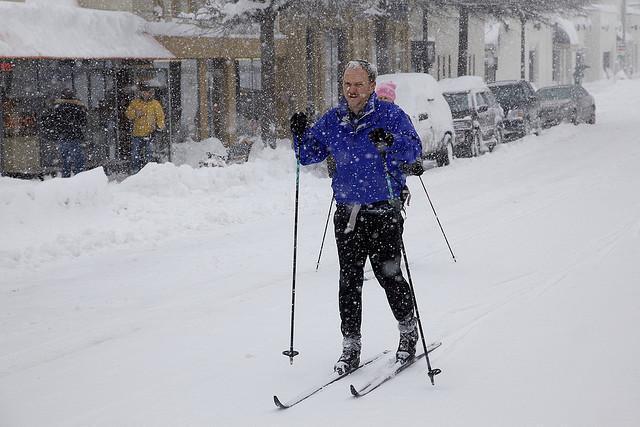How many skiers are there?
Give a very brief answer. 1. How many vehicles are in the background?
Give a very brief answer. 4. How many people are there?
Give a very brief answer. 3. How many cars can you see?
Give a very brief answer. 4. 